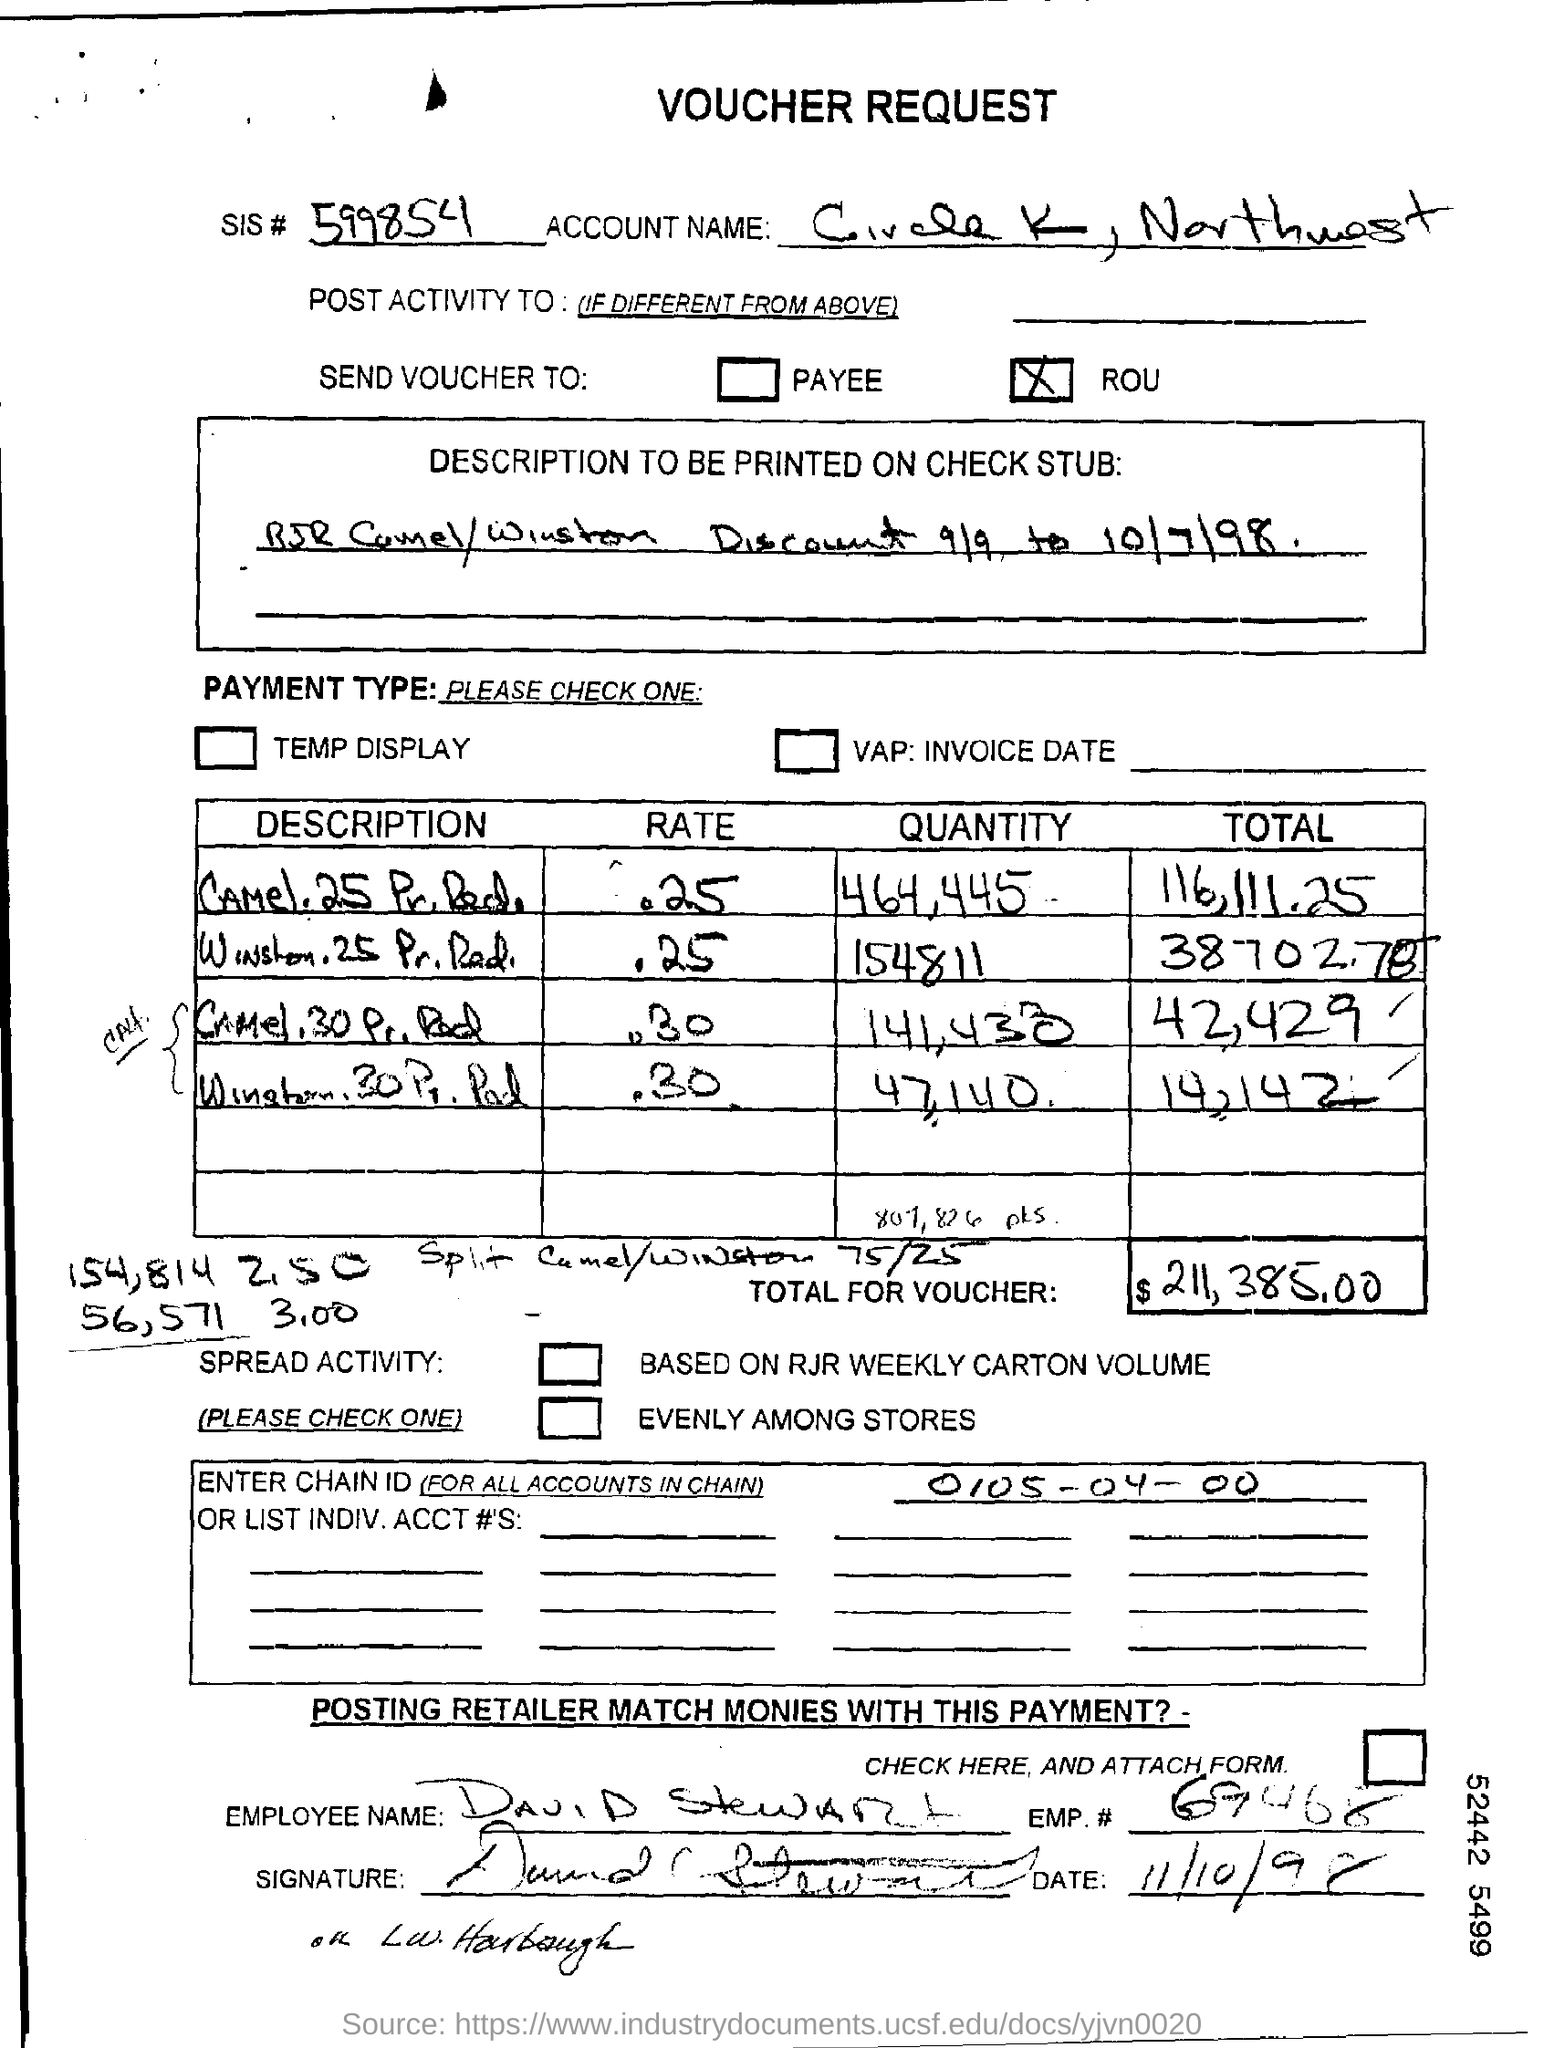Outline some significant characteristics in this image. The description to be printed on the check stub is "RJR Camel/Winston Discount from 9/9 to 10/7/98. What is the chain ID specified in the voucher request form? It is 0105-04-00... The total amount mentioned in the voucher is $211,385.00. The voucher request form contains a SIS number of 599854... The employee number of David Stewart is 69468. 